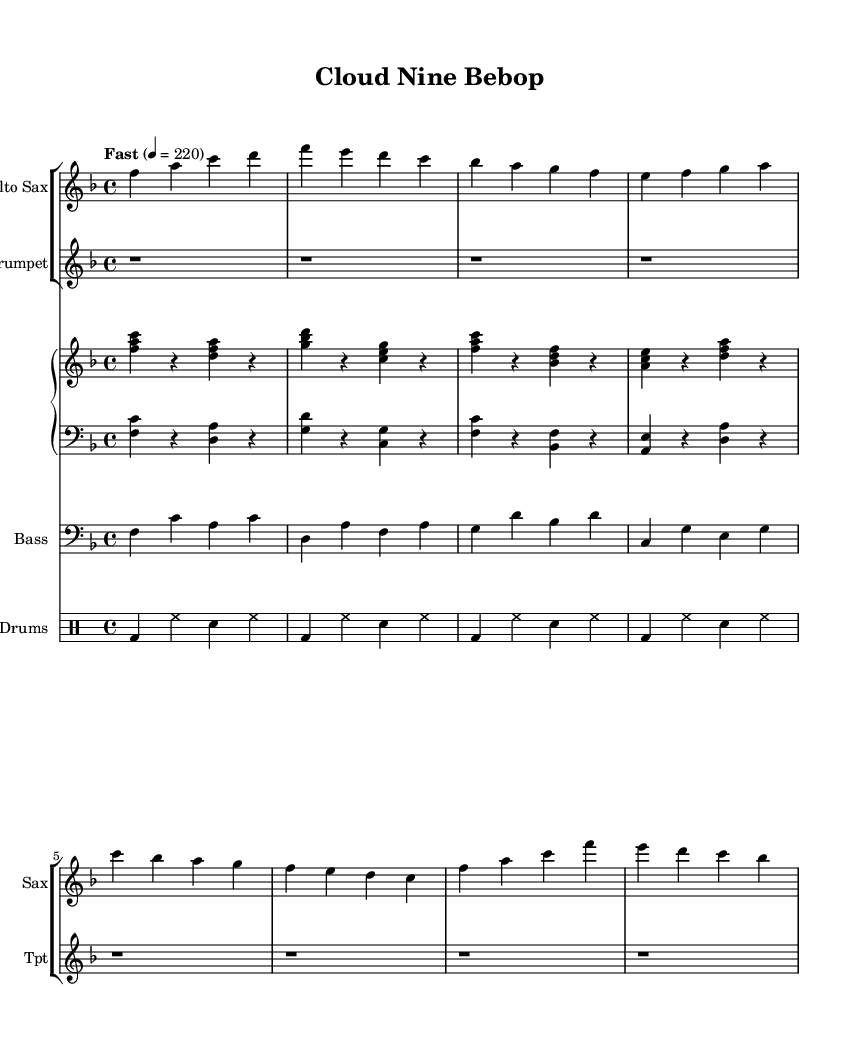What is the key signature of this music? The key signature is F major, which has one flat (B flat). It can be identified by looking at the key signature indicators at the beginning of the staff.
Answer: F major What is the time signature of this piece? The time signature is 4/4, indicated by the numbers at the beginning of the staff. This means there are four beats in each measure and the quarter note receives one beat.
Answer: 4/4 What is the tempo marking for this piece? The tempo marking is "Fast" with a metronome marking of 220 beats per minute, shown at the beginning of the score. This indicates the speed at which the piece should be played.
Answer: Fast, 220 How many measures are in the saxophone part? The saxophone part consists of 8 measures, counted by examining the bars in the provided music notation.
Answer: 8 measures What is the main rhythmic feature present in the drums part? The main rhythmic feature in the drums part is a steady quarter note bass drum followed by alternating hi-hat and snare. This pattern creates an energetic groove typical in Bebop jazz.
Answer: Steady quarter notes What is the role of the piano in this piece? The role of the piano is to provide harmonic support and rhythmic counterpoint with chord voicings in the right hand and bass notes in the left hand, contributing to the overall texture of the piece.
Answer: Harmonic support What is the style of the music indicated in the title? The title "Cloud Nine Bebop" suggests an upbeat jazz style characteristic of Bebop, which is known for its fast tempos, complex chords, and improvisational nature.
Answer: Bebop 